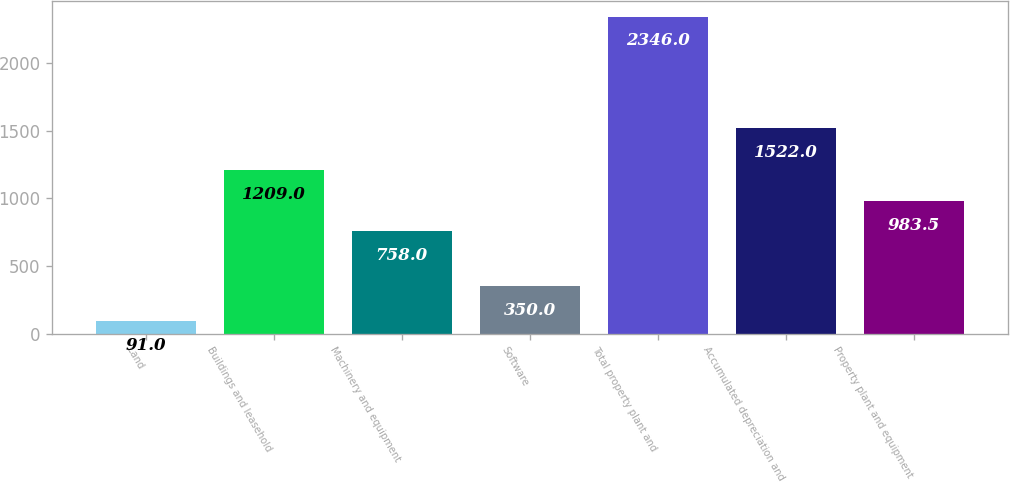Convert chart to OTSL. <chart><loc_0><loc_0><loc_500><loc_500><bar_chart><fcel>Land<fcel>Buildings and leasehold<fcel>Machinery and equipment<fcel>Software<fcel>Total property plant and<fcel>Accumulated depreciation and<fcel>Property plant and equipment<nl><fcel>91<fcel>1209<fcel>758<fcel>350<fcel>2346<fcel>1522<fcel>983.5<nl></chart> 